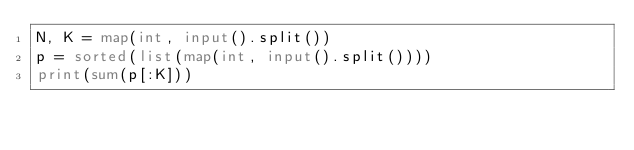Convert code to text. <code><loc_0><loc_0><loc_500><loc_500><_Python_>N, K = map(int, input().split())
p = sorted(list(map(int, input().split())))
print(sum(p[:K]))</code> 